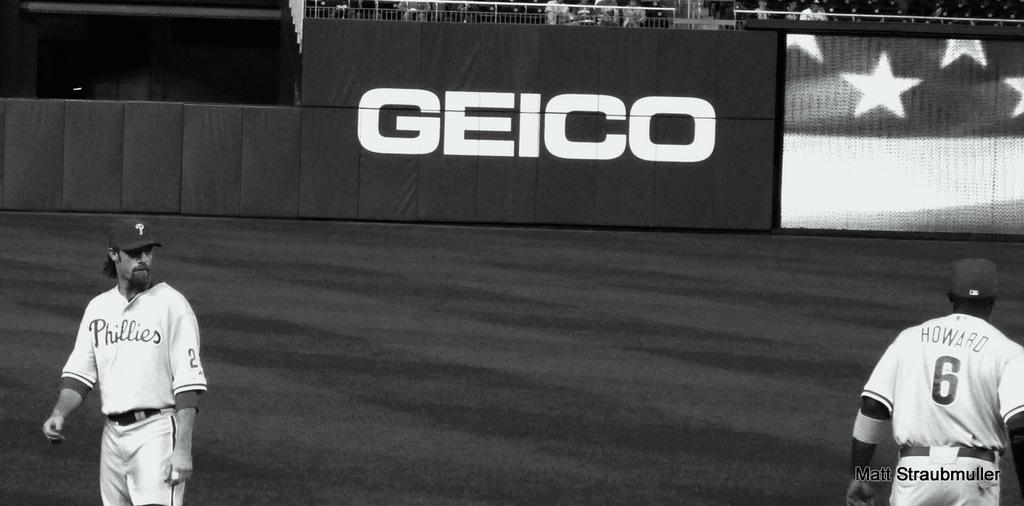<image>
Relay a brief, clear account of the picture shown. Two Phillies baseball players are seen in a black and white photo on the field in front of a huge GEICO advertisement. 